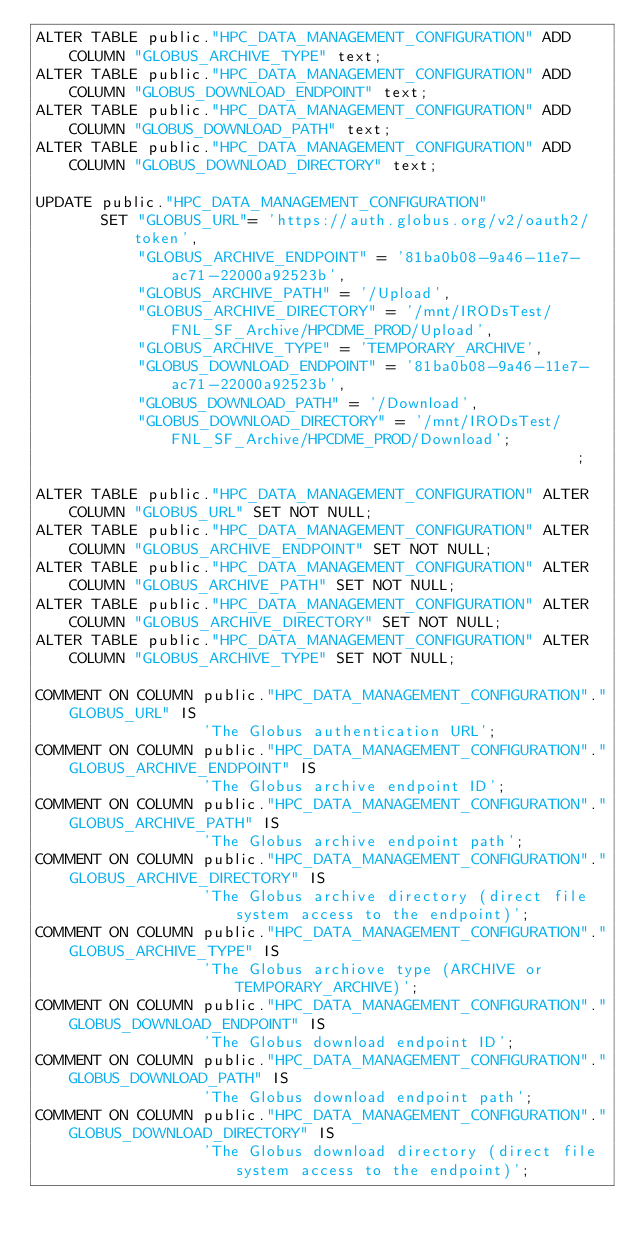Convert code to text. <code><loc_0><loc_0><loc_500><loc_500><_SQL_>ALTER TABLE public."HPC_DATA_MANAGEMENT_CONFIGURATION" ADD COLUMN "GLOBUS_ARCHIVE_TYPE" text;
ALTER TABLE public."HPC_DATA_MANAGEMENT_CONFIGURATION" ADD COLUMN "GLOBUS_DOWNLOAD_ENDPOINT" text;
ALTER TABLE public."HPC_DATA_MANAGEMENT_CONFIGURATION" ADD COLUMN "GLOBUS_DOWNLOAD_PATH" text;
ALTER TABLE public."HPC_DATA_MANAGEMENT_CONFIGURATION" ADD COLUMN "GLOBUS_DOWNLOAD_DIRECTORY" text;

UPDATE public."HPC_DATA_MANAGEMENT_CONFIGURATION" 
       SET "GLOBUS_URL"= 'https://auth.globus.org/v2/oauth2/token', 
           "GLOBUS_ARCHIVE_ENDPOINT" = '81ba0b08-9a46-11e7-ac71-22000a92523b',
           "GLOBUS_ARCHIVE_PATH" = '/Upload',
           "GLOBUS_ARCHIVE_DIRECTORY" = '/mnt/IRODsTest/FNL_SF_Archive/HPCDME_PROD/Upload',
           "GLOBUS_ARCHIVE_TYPE" = 'TEMPORARY_ARCHIVE',
           "GLOBUS_DOWNLOAD_ENDPOINT" = '81ba0b08-9a46-11e7-ac71-22000a92523b',
           "GLOBUS_DOWNLOAD_PATH" = '/Download',
           "GLOBUS_DOWNLOAD_DIRECTORY" = '/mnt/IRODsTest/FNL_SF_Archive/HPCDME_PROD/Download';                                             ;

ALTER TABLE public."HPC_DATA_MANAGEMENT_CONFIGURATION" ALTER COLUMN "GLOBUS_URL" SET NOT NULL;
ALTER TABLE public."HPC_DATA_MANAGEMENT_CONFIGURATION" ALTER COLUMN "GLOBUS_ARCHIVE_ENDPOINT" SET NOT NULL;
ALTER TABLE public."HPC_DATA_MANAGEMENT_CONFIGURATION" ALTER COLUMN "GLOBUS_ARCHIVE_PATH" SET NOT NULL;
ALTER TABLE public."HPC_DATA_MANAGEMENT_CONFIGURATION" ALTER COLUMN "GLOBUS_ARCHIVE_DIRECTORY" SET NOT NULL;
ALTER TABLE public."HPC_DATA_MANAGEMENT_CONFIGURATION" ALTER COLUMN "GLOBUS_ARCHIVE_TYPE" SET NOT NULL;

COMMENT ON COLUMN public."HPC_DATA_MANAGEMENT_CONFIGURATION"."GLOBUS_URL" IS 
                  'The Globus authentication URL';    
COMMENT ON COLUMN public."HPC_DATA_MANAGEMENT_CONFIGURATION"."GLOBUS_ARCHIVE_ENDPOINT" IS 
                  'The Globus archive endpoint ID';    
COMMENT ON COLUMN public."HPC_DATA_MANAGEMENT_CONFIGURATION"."GLOBUS_ARCHIVE_PATH" IS 
                  'The Globus archive endpoint path';    
COMMENT ON COLUMN public."HPC_DATA_MANAGEMENT_CONFIGURATION"."GLOBUS_ARCHIVE_DIRECTORY" IS 
                  'The Globus archive directory (direct file system access to the endpoint)';    
COMMENT ON COLUMN public."HPC_DATA_MANAGEMENT_CONFIGURATION"."GLOBUS_ARCHIVE_TYPE" IS 
                  'The Globus archiove type (ARCHIVE or TEMPORARY_ARCHIVE)';    
COMMENT ON COLUMN public."HPC_DATA_MANAGEMENT_CONFIGURATION"."GLOBUS_DOWNLOAD_ENDPOINT" IS 
                  'The Globus download endpoint ID';    
COMMENT ON COLUMN public."HPC_DATA_MANAGEMENT_CONFIGURATION"."GLOBUS_DOWNLOAD_PATH" IS 
                  'The Globus download endpoint path';    
COMMENT ON COLUMN public."HPC_DATA_MANAGEMENT_CONFIGURATION"."GLOBUS_DOWNLOAD_DIRECTORY" IS 
                  'The Globus download directory (direct file system access to the endpoint)';  
</code> 